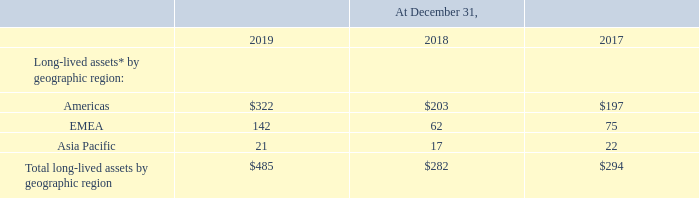Long-lived assets by geographic region were as follows (amounts in millions):
The only long-lived assets that we classify by region are our long-term tangible fixed assets, which consist of property, plant, and equipment assets, and beginning with 2019, as a result of our adoption of a new lease accounting standard, our lease ROU assets; all other long-term assets are not allocated by location.
For information regarding significant customers, see “Concentration of Credit Risk” in Note 2.
What does the company's long-term tangible fixed assets consist of? Property, plant, and equipment assets, and beginning with 2019, as a result of our adoption of a new lease accounting standard, our lease rou assets. What was the long-lived assets in Americas in 2019?
Answer scale should be: million. 322. What was the long-lived assets in EMEA in 2019?
Answer scale should be: million. 142. What was the percentage change in the long-lived assets in Americas between 2018 and 2019?
Answer scale should be: percent. ($322-$203)/$203
Answer: 58.62. What was the percentage change in the long-lived assets in Asia Pacific between 2018 and 2019?
Answer scale should be: percent. (21-17)/17
Answer: 23.53. What was the change in total long-lived assets by geographical region between 2017 and 2018?
Answer scale should be: million. 282-294
Answer: -12. 